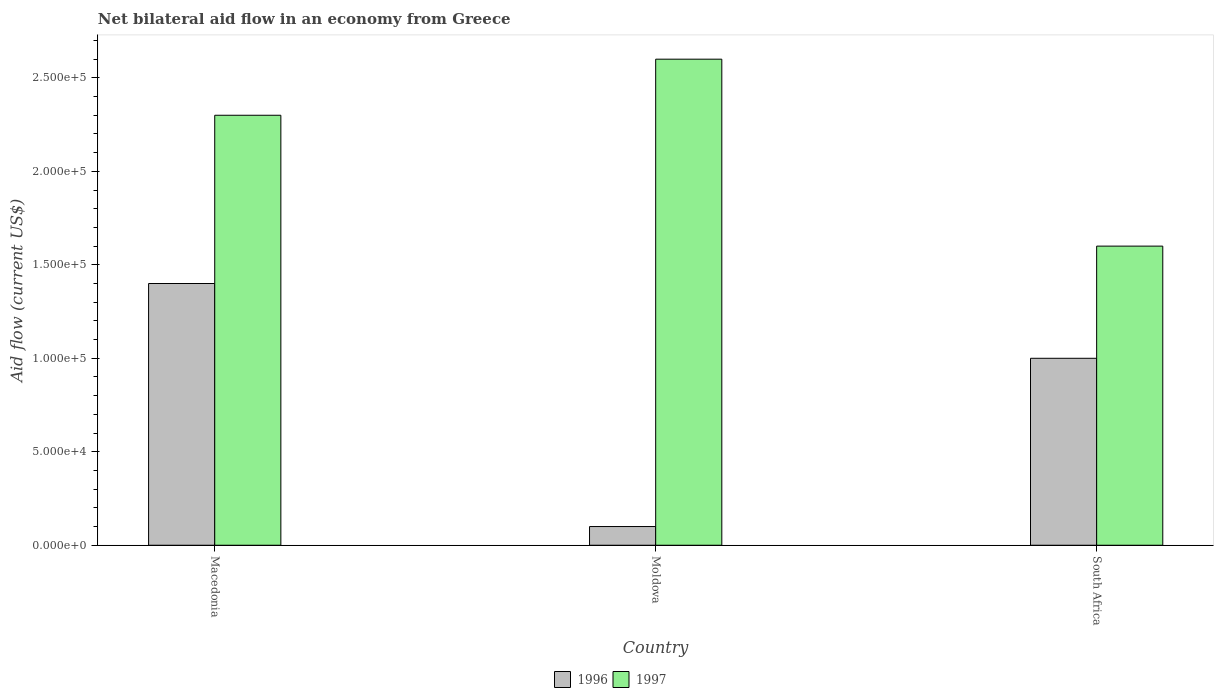Are the number of bars per tick equal to the number of legend labels?
Ensure brevity in your answer.  Yes. How many bars are there on the 3rd tick from the left?
Give a very brief answer. 2. How many bars are there on the 1st tick from the right?
Offer a very short reply. 2. What is the label of the 1st group of bars from the left?
Your response must be concise. Macedonia. In how many cases, is the number of bars for a given country not equal to the number of legend labels?
Provide a succinct answer. 0. Across all countries, what is the maximum net bilateral aid flow in 1996?
Keep it short and to the point. 1.40e+05. Across all countries, what is the minimum net bilateral aid flow in 1997?
Provide a short and direct response. 1.60e+05. In which country was the net bilateral aid flow in 1996 maximum?
Your answer should be compact. Macedonia. In which country was the net bilateral aid flow in 1997 minimum?
Your answer should be compact. South Africa. What is the total net bilateral aid flow in 1996 in the graph?
Give a very brief answer. 2.50e+05. What is the difference between the net bilateral aid flow in 1997 in Macedonia and the net bilateral aid flow in 1996 in Moldova?
Ensure brevity in your answer.  2.20e+05. What is the average net bilateral aid flow in 1997 per country?
Provide a short and direct response. 2.17e+05. What is the difference between the net bilateral aid flow of/in 1997 and net bilateral aid flow of/in 1996 in Macedonia?
Your answer should be very brief. 9.00e+04. In how many countries, is the net bilateral aid flow in 1997 greater than 190000 US$?
Keep it short and to the point. 2. What is the ratio of the net bilateral aid flow in 1997 in Moldova to that in South Africa?
Keep it short and to the point. 1.62. What is the difference between the highest and the second highest net bilateral aid flow in 1997?
Make the answer very short. 1.00e+05. Is the sum of the net bilateral aid flow in 1996 in Macedonia and South Africa greater than the maximum net bilateral aid flow in 1997 across all countries?
Offer a terse response. No. What does the 1st bar from the right in Macedonia represents?
Ensure brevity in your answer.  1997. Are all the bars in the graph horizontal?
Provide a short and direct response. No. How many countries are there in the graph?
Provide a short and direct response. 3. Where does the legend appear in the graph?
Keep it short and to the point. Bottom center. What is the title of the graph?
Offer a very short reply. Net bilateral aid flow in an economy from Greece. What is the label or title of the X-axis?
Offer a very short reply. Country. What is the label or title of the Y-axis?
Keep it short and to the point. Aid flow (current US$). What is the Aid flow (current US$) in 1996 in South Africa?
Offer a very short reply. 1.00e+05. What is the Aid flow (current US$) in 1997 in South Africa?
Make the answer very short. 1.60e+05. Across all countries, what is the maximum Aid flow (current US$) in 1996?
Provide a short and direct response. 1.40e+05. What is the total Aid flow (current US$) of 1997 in the graph?
Your response must be concise. 6.50e+05. What is the difference between the Aid flow (current US$) of 1997 in Macedonia and that in Moldova?
Provide a succinct answer. -3.00e+04. What is the difference between the Aid flow (current US$) of 1996 in Macedonia and that in South Africa?
Ensure brevity in your answer.  4.00e+04. What is the difference between the Aid flow (current US$) in 1996 in Moldova and the Aid flow (current US$) in 1997 in South Africa?
Offer a terse response. -1.50e+05. What is the average Aid flow (current US$) in 1996 per country?
Offer a terse response. 8.33e+04. What is the average Aid flow (current US$) of 1997 per country?
Ensure brevity in your answer.  2.17e+05. What is the difference between the Aid flow (current US$) of 1996 and Aid flow (current US$) of 1997 in South Africa?
Your response must be concise. -6.00e+04. What is the ratio of the Aid flow (current US$) in 1997 in Macedonia to that in Moldova?
Give a very brief answer. 0.88. What is the ratio of the Aid flow (current US$) of 1997 in Macedonia to that in South Africa?
Provide a short and direct response. 1.44. What is the ratio of the Aid flow (current US$) in 1997 in Moldova to that in South Africa?
Provide a succinct answer. 1.62. 